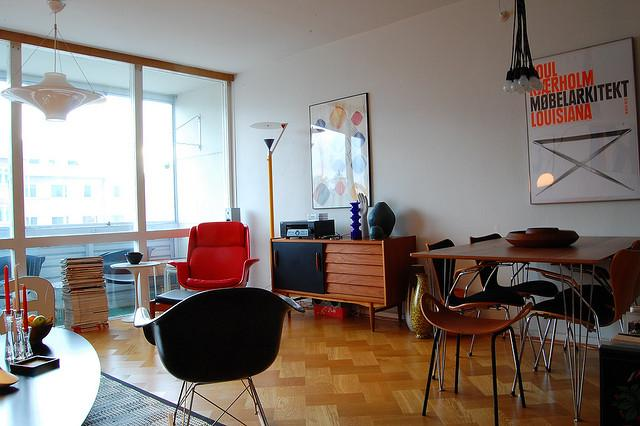What is next to the table on the left? Please explain your reasoning. black chair. This is the closest piece of furniture to the table 